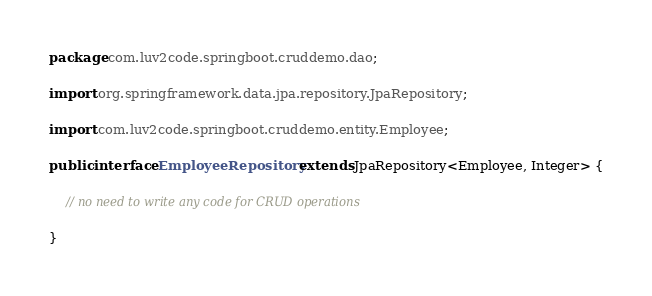Convert code to text. <code><loc_0><loc_0><loc_500><loc_500><_Java_>package com.luv2code.springboot.cruddemo.dao;

import org.springframework.data.jpa.repository.JpaRepository;

import com.luv2code.springboot.cruddemo.entity.Employee;

public interface EmployeeRepository extends JpaRepository<Employee, Integer> {
	
	// no need to write any code for CRUD operations

}
</code> 